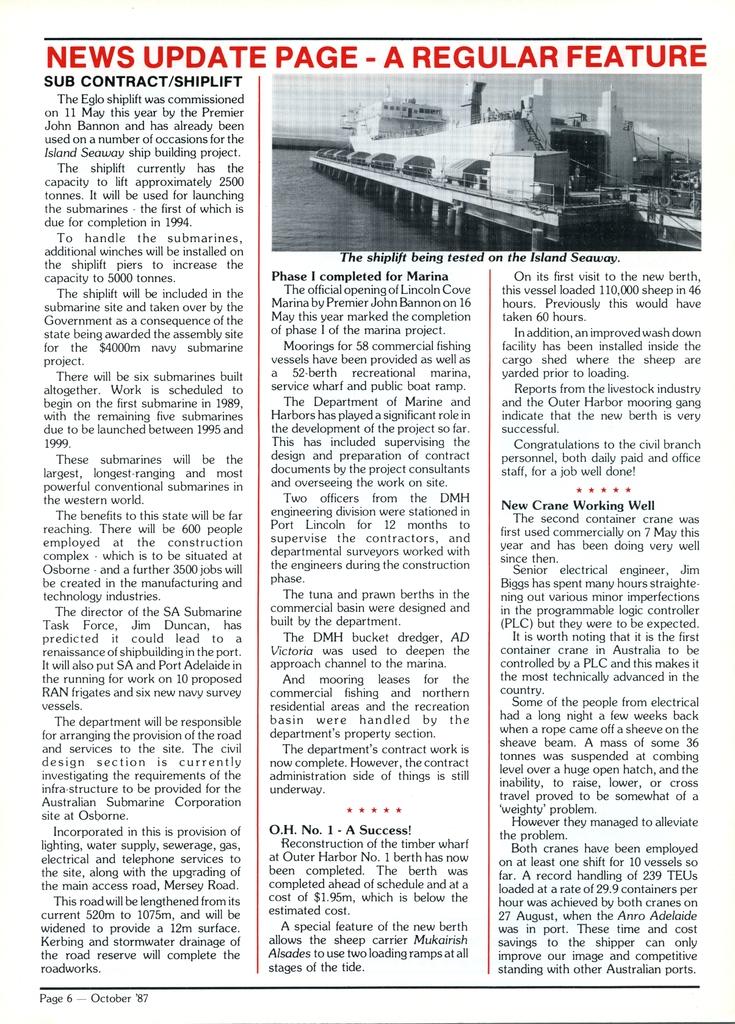The news update page is?
Provide a short and direct response. A regular feature. What page is this for?
Give a very brief answer. News update. 